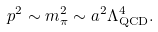Convert formula to latex. <formula><loc_0><loc_0><loc_500><loc_500>p ^ { 2 } \sim m _ { \pi } ^ { 2 } \sim a ^ { 2 } \Lambda _ { \text {QCD} } ^ { 4 } .</formula> 